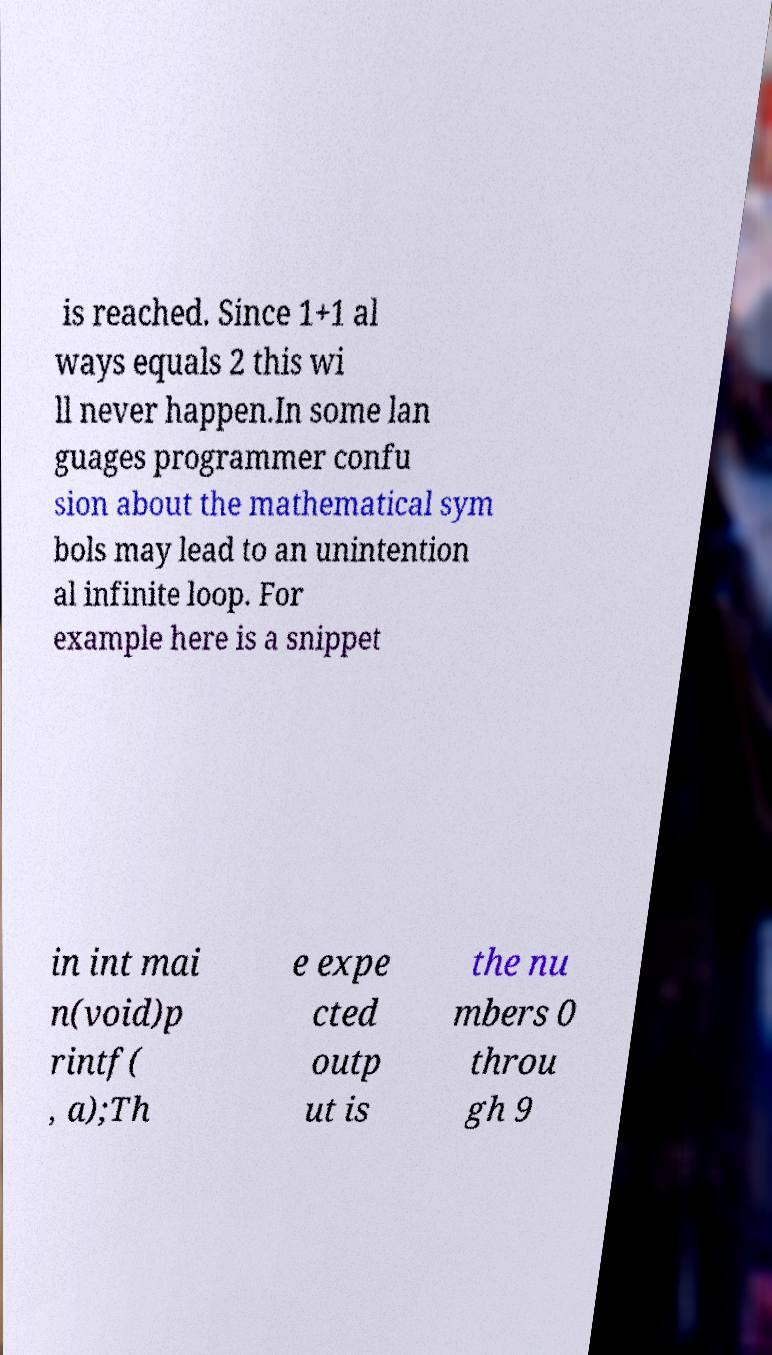What messages or text are displayed in this image? I need them in a readable, typed format. is reached. Since 1+1 al ways equals 2 this wi ll never happen.In some lan guages programmer confu sion about the mathematical sym bols may lead to an unintention al infinite loop. For example here is a snippet in int mai n(void)p rintf( , a);Th e expe cted outp ut is the nu mbers 0 throu gh 9 